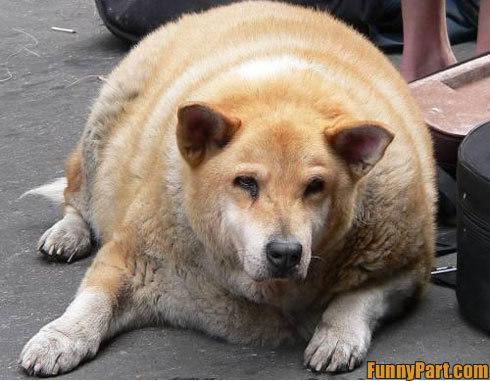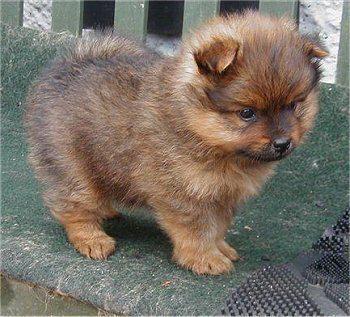The first image is the image on the left, the second image is the image on the right. Analyze the images presented: Is the assertion "There is a human in the image on the right." valid? Answer yes or no. No. 